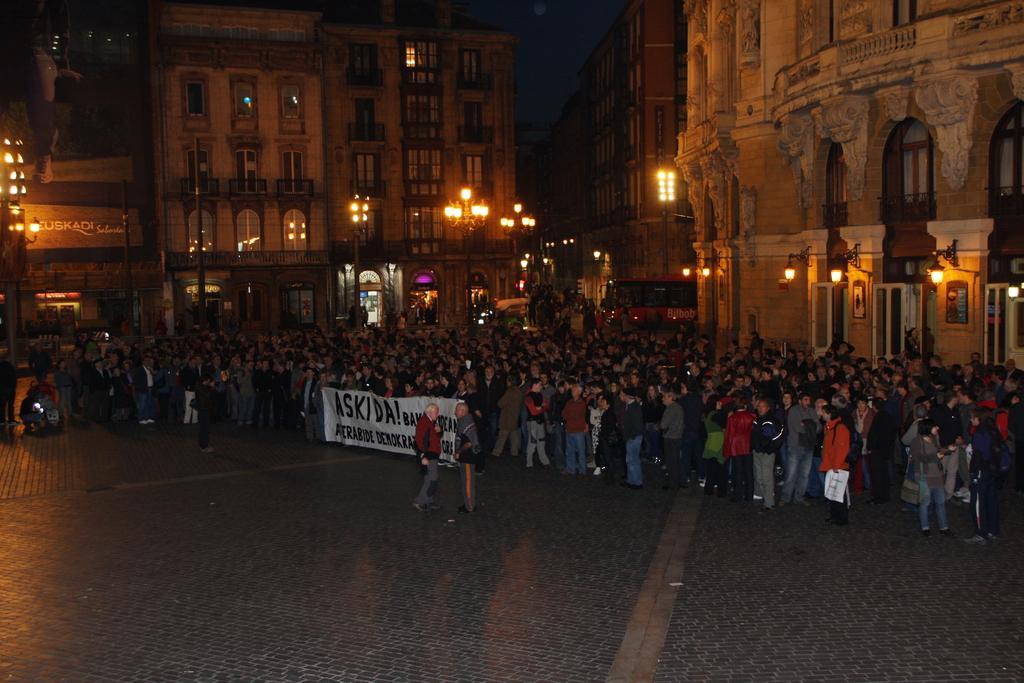In one or two sentences, can you explain what this image depicts? In this image I can see group of people standing. In the middle of the picture there is some text. In the background there are few buildings. 